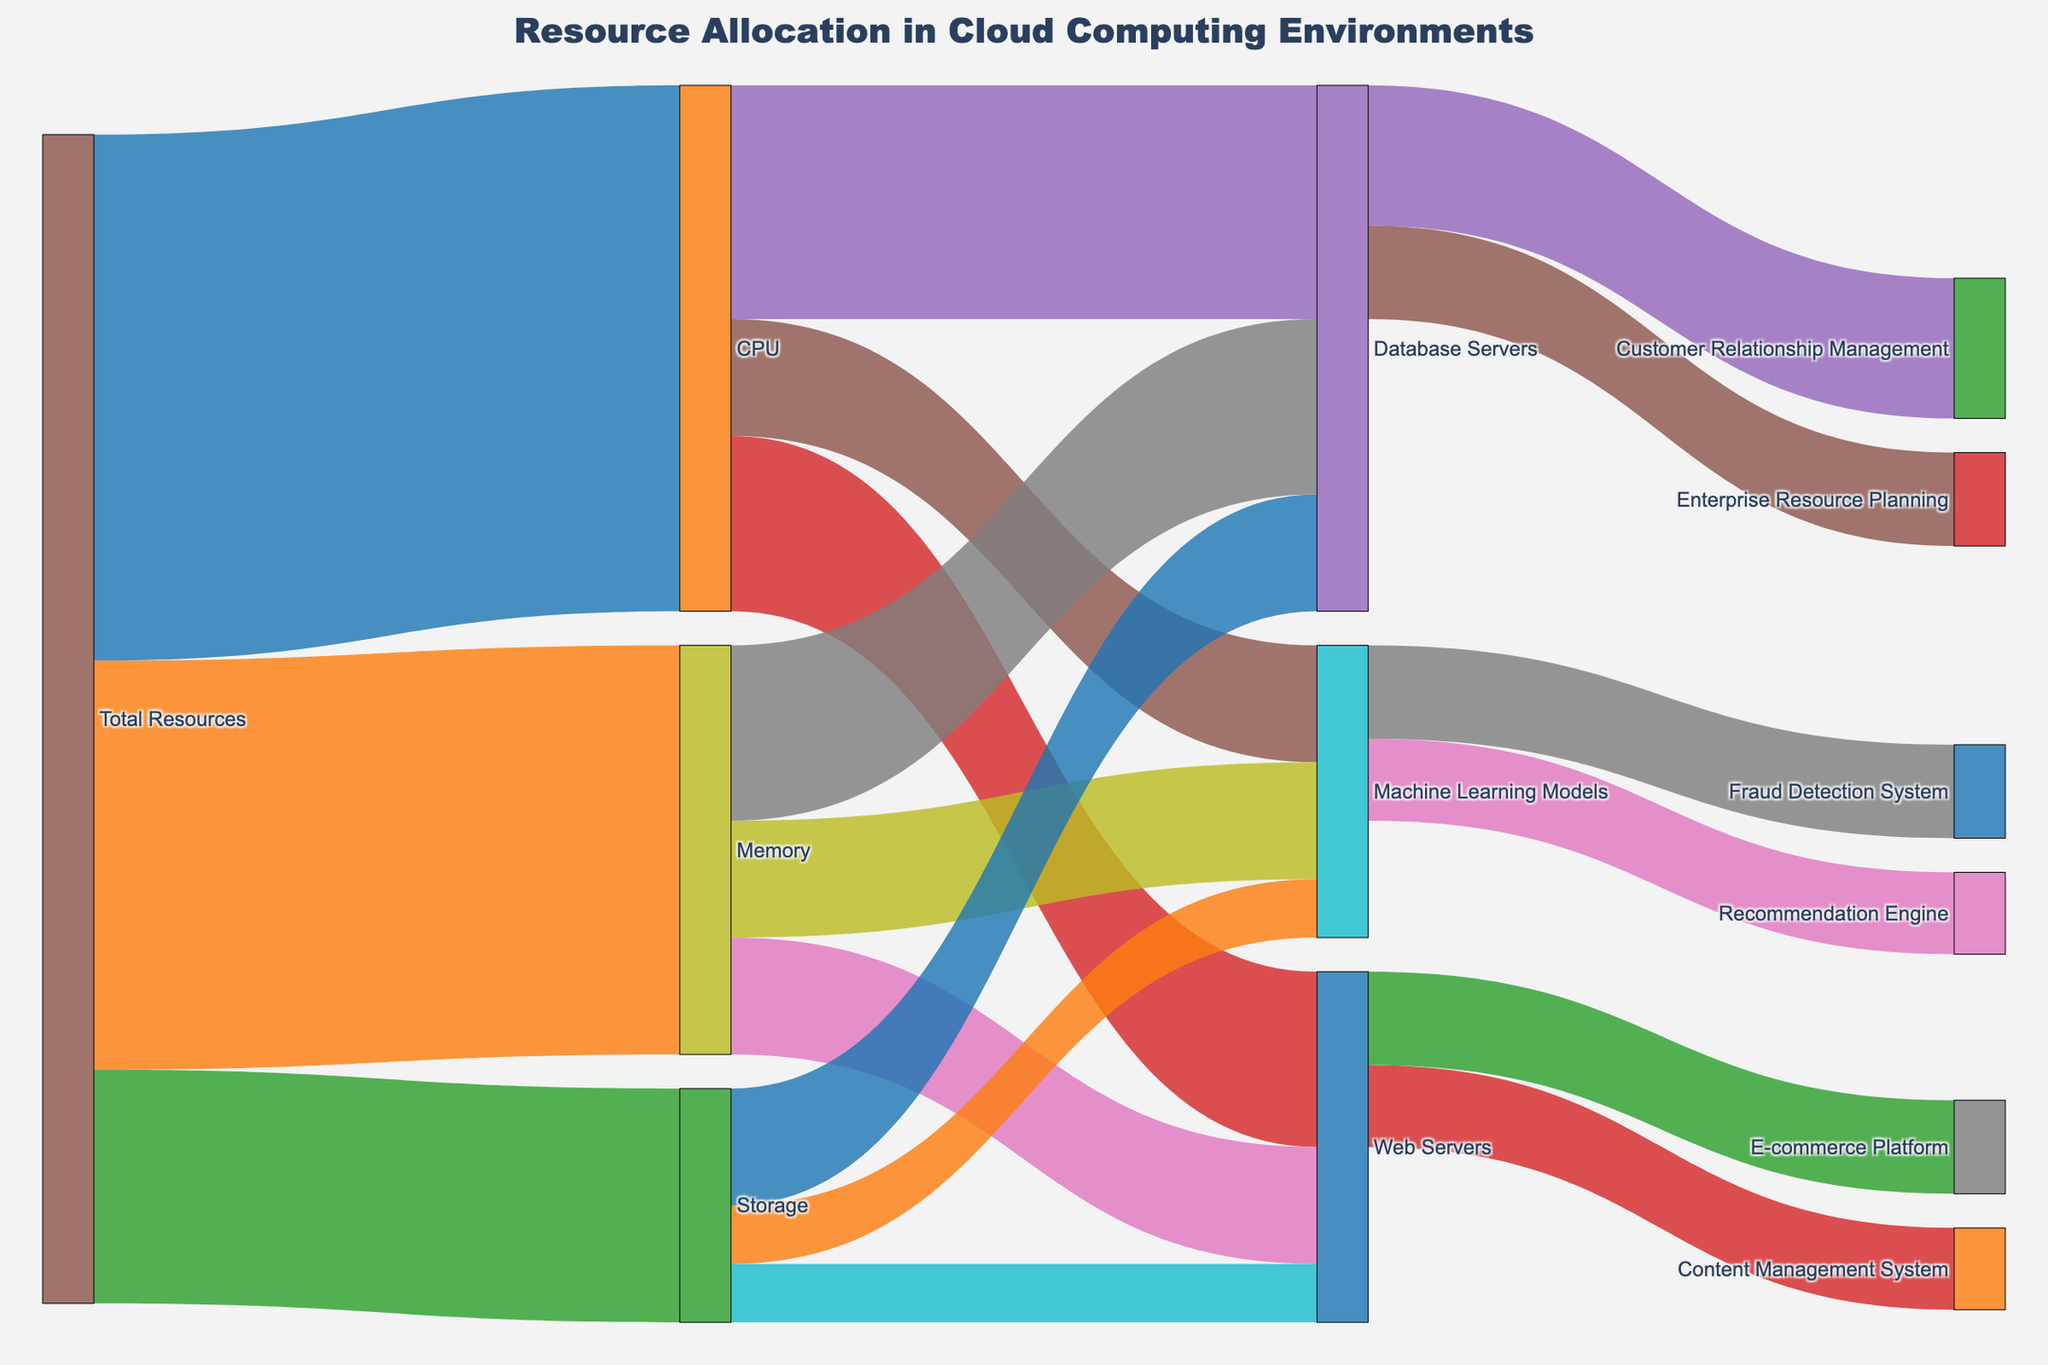What is the total allocation of CPU resources to Machine Learning Models? To find the total allocation, you locate the "CPU" node and follow its connections to "Machine Learning Models." The data shows a flow value of 10 from "CPU" to "Machine Learning Models."
Answer: 10 Which application type has the highest allocation of memory resources? To determine this, look at the connections from "Memory" to various targets. The values are: Web Servers (10), Database Servers (15), and Machine Learning Models (10). Database Servers have the highest allocation of memory resources with a value of 15.
Answer: Database Servers How much storage is allocated to the Web Servers? To find this, identify the connection from "Storage" to "Web Servers" on the Sankey diagram. The flow value is 5.
Answer: 5 Compare the total resources allocated to Database Servers and Machine Learning Models. Which one has more resources? To compare, sum up the respective allocations for CPU, Memory, and Storage. Database Servers have CPU (20) + Memory (15) + Storage (10) = 45. Machine Learning Models have CPU (10) + Memory (10) + Storage (5) = 25. Database Servers have more resources.
Answer: Database Servers What is the allocation of CPU resources to the Database Servers compared to the Web Servers? The Sankey diagram shows the allocated CPU resources as 20 for Database Servers and 15 for Web Servers. Comparing them, the Database Servers have 5 more CPU resources than Web Servers.
Answer: Database Servers have 5 more Which service has the highest overall resource allocation? To find this, sum the resources allocated to each service (E-commerce Platform, Content Management System, etc.). Calculate: E-commerce Platform with Web Servers (8) + Content Management System with Web Servers (7) = 15; Customer Relationship Management with Database Servers (12) + Enterprise Resource Planning with Database Servers (8) = 20; Recommendation Engine with Machine Learning Models (7) + Fraud Detection System with Machine Learning Models (8) = 15. Customer Relationship Management has the highest with 20.
Answer: Customer Relationship Management What is the total amount of resource allocation to the E-commerce Platform? To determine this, locate the connection from "Web Servers" to "E-commerce Platform" on the Sankey diagram. The value is 8.
Answer: 8 How are storage resources distributed among the Web Servers, Database Servers, and Machine Learning Models? To determine this, follow the connections from "Storage" to each of its targets. The values are: Web Servers (5), Database Servers (10), and Machine Learning Models (5).
Answer: Web Servers: 5, Database Servers: 10, Machine Learning Models: 5 What is the total allocation of resources to the Web Servers? To calculate the total resources allocated to the Web Servers, sum up CPU, Memory, and Storage. The values are CPU (15) + Memory (10) + Storage (5) = 30.
Answer: 30 Which application utilizes the least CPU resources? Look for the lowest value in the CPU resource allocations. The values are Web Servers (15), Database Servers (20), and Machine Learning Models (10). Machine Learning Models have the least CPU allocation with a value of 10.
Answer: Machine Learning Models 